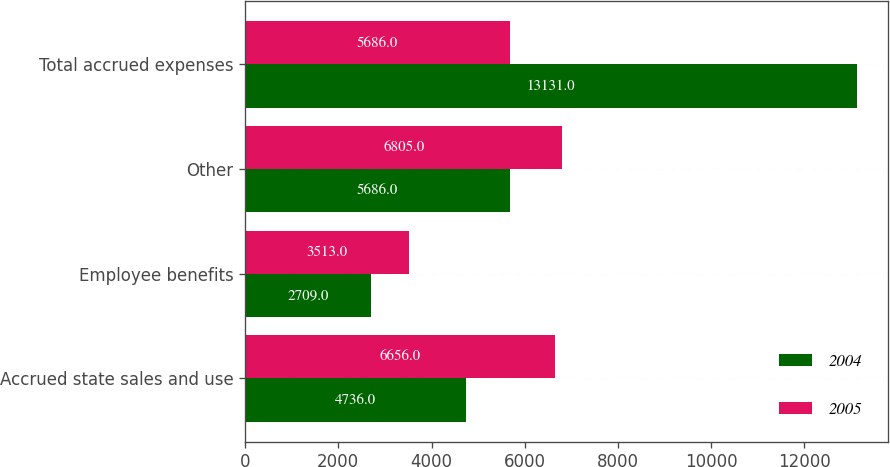Convert chart. <chart><loc_0><loc_0><loc_500><loc_500><stacked_bar_chart><ecel><fcel>Accrued state sales and use<fcel>Employee benefits<fcel>Other<fcel>Total accrued expenses<nl><fcel>2004<fcel>4736<fcel>2709<fcel>5686<fcel>13131<nl><fcel>2005<fcel>6656<fcel>3513<fcel>6805<fcel>5686<nl></chart> 